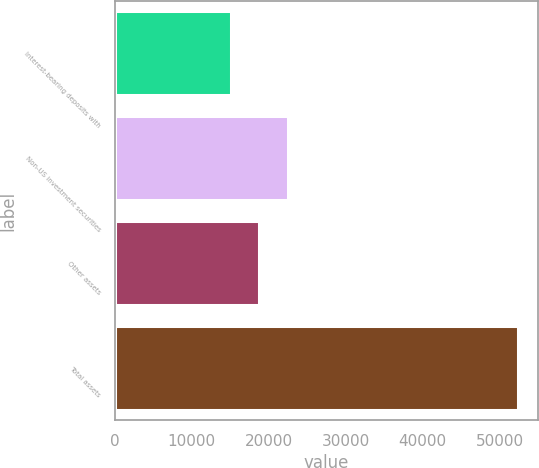<chart> <loc_0><loc_0><loc_500><loc_500><bar_chart><fcel>Interest-bearing deposits with<fcel>Non-US investment securities<fcel>Other assets<fcel>Total assets<nl><fcel>15052<fcel>22501.4<fcel>18776.7<fcel>52299<nl></chart> 